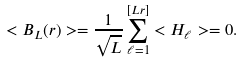Convert formula to latex. <formula><loc_0><loc_0><loc_500><loc_500>< B _ { L } ( r ) > = \frac { 1 } { \sqrt { L } } \sum _ { \ell = 1 } ^ { [ L r ] } < H _ { \ell } > = 0 .</formula> 